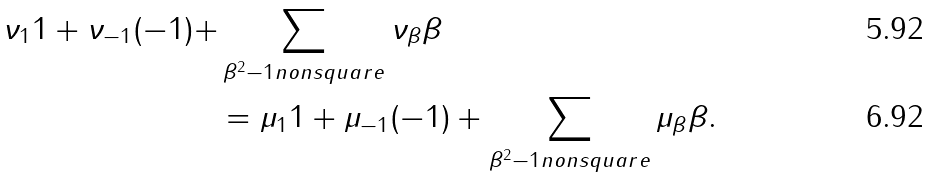<formula> <loc_0><loc_0><loc_500><loc_500>\nu _ { 1 } 1 + \nu _ { - 1 } ( - 1 ) + & \sum _ { \beta ^ { 2 } - 1 n o n s q u a r e } \nu _ { \beta } \beta \\ & = \mu _ { 1 } 1 + \mu _ { - 1 } ( - 1 ) + \sum _ { \beta ^ { 2 } - 1 n o n s q u a r e } \mu _ { \beta } \beta .</formula> 